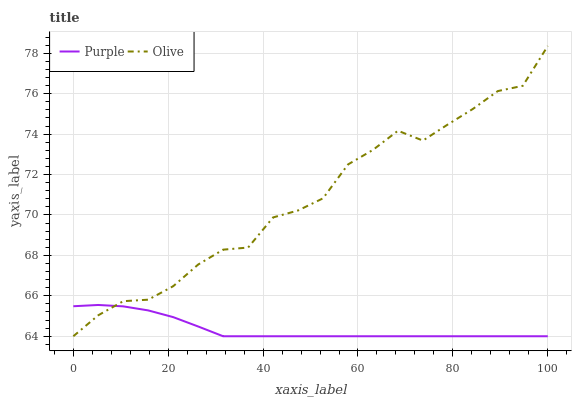Does Purple have the minimum area under the curve?
Answer yes or no. Yes. Does Olive have the maximum area under the curve?
Answer yes or no. Yes. Does Olive have the minimum area under the curve?
Answer yes or no. No. Is Purple the smoothest?
Answer yes or no. Yes. Is Olive the roughest?
Answer yes or no. Yes. Is Olive the smoothest?
Answer yes or no. No. Does Purple have the lowest value?
Answer yes or no. Yes. Does Olive have the highest value?
Answer yes or no. Yes. Does Purple intersect Olive?
Answer yes or no. Yes. Is Purple less than Olive?
Answer yes or no. No. Is Purple greater than Olive?
Answer yes or no. No. 